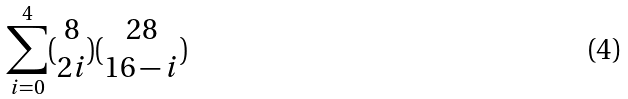Convert formula to latex. <formula><loc_0><loc_0><loc_500><loc_500>\sum _ { i = 0 } ^ { 4 } ( \begin{matrix} 8 \\ 2 i \end{matrix} ) ( \begin{matrix} 2 8 \\ 1 6 - i \end{matrix} )</formula> 